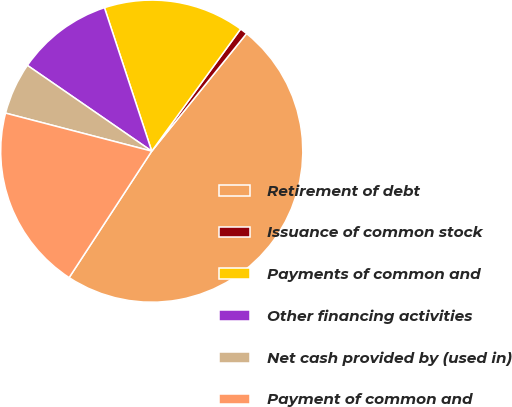Convert chart to OTSL. <chart><loc_0><loc_0><loc_500><loc_500><pie_chart><fcel>Retirement of debt<fcel>Issuance of common stock<fcel>Payments of common and<fcel>Other financing activities<fcel>Net cash provided by (used in)<fcel>Payment of common and<nl><fcel>48.41%<fcel>0.79%<fcel>15.08%<fcel>10.32%<fcel>5.56%<fcel>19.84%<nl></chart> 